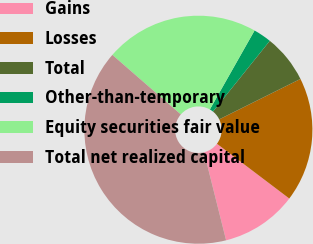<chart> <loc_0><loc_0><loc_500><loc_500><pie_chart><fcel>Gains<fcel>Losses<fcel>Total<fcel>Other-than-temporary<fcel>Equity securities fair value<fcel>Total net realized capital<nl><fcel>10.78%<fcel>17.66%<fcel>6.88%<fcel>2.57%<fcel>21.81%<fcel>40.3%<nl></chart> 